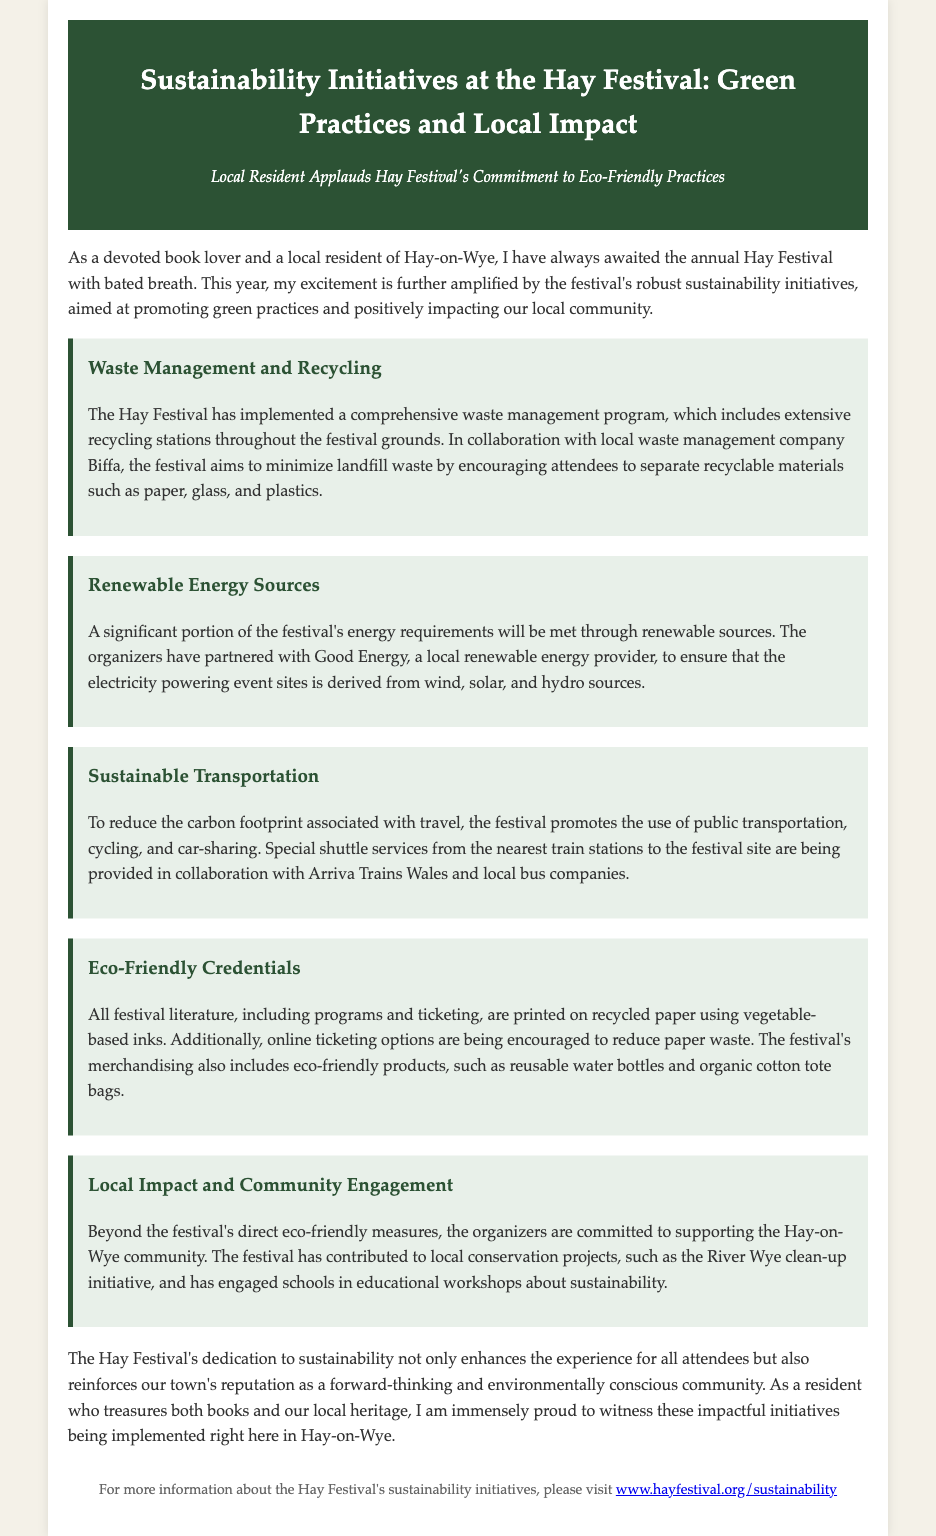What is the main theme of the press release? The press release focuses on the sustainability initiatives implemented at the Hay Festival.
Answer: Sustainability initiatives Who is the local waste management partner mentioned? The document states that the festival collaborates with Biffa for waste management.
Answer: Biffa What type of energy sources are used at the festival? The festival partners with Good Energy to meet energy needs through renewable sources like wind and solar.
Answer: Renewable sources What transportation methods does the festival encourage? The Hay Festival promotes public transportation, cycling, and car-sharing to reduce carbon footprint.
Answer: Public transportation, cycling, car-sharing What materials are used for festival literature? All festival literature is printed on recycled paper using vegetable-based inks.
Answer: Recycled paper Which community initiative does the festival support? The festival contributes to local projects like the River Wye clean-up initiative.
Answer: River Wye clean-up initiative What type of products are included in the festival's merchandising? The merchandising includes eco-friendly products such as reusable water bottles.
Answer: Reusable water bottles How has the festival engaged local schools? The festival organizes educational workshops about sustainability in local schools.
Answer: Educational workshops What is the main benefit of the festival's sustainability efforts? The initiatives enhance the attendee experience and reinforce the town's reputation for being environmentally conscious.
Answer: Enhance attendee experience 